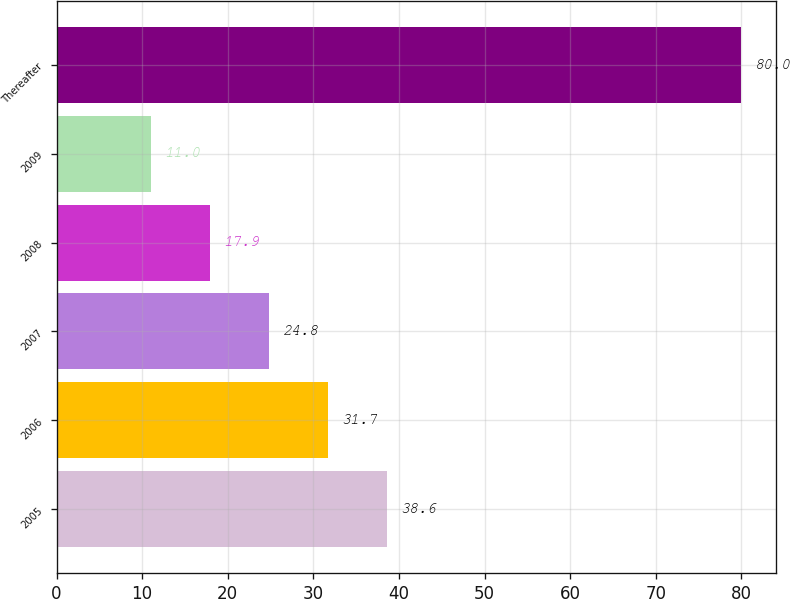Convert chart to OTSL. <chart><loc_0><loc_0><loc_500><loc_500><bar_chart><fcel>2005<fcel>2006<fcel>2007<fcel>2008<fcel>2009<fcel>Thereafter<nl><fcel>38.6<fcel>31.7<fcel>24.8<fcel>17.9<fcel>11<fcel>80<nl></chart> 